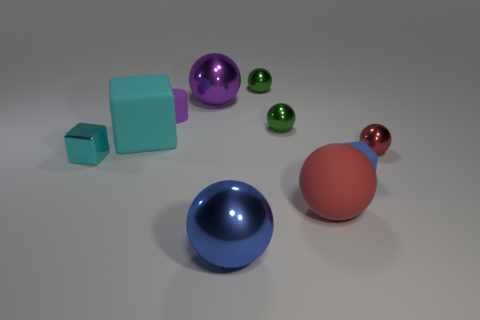Subtract all red balls. How many were subtracted if there are1red balls left? 1 Subtract all purple cylinders. How many cyan cubes are left? 2 Subtract all cyan rubber cubes. How many cubes are left? 2 Subtract all blue cubes. How many cubes are left? 2 Subtract all small red spheres. Subtract all small purple matte cylinders. How many objects are left? 8 Add 2 rubber cubes. How many rubber cubes are left? 4 Add 9 large green shiny balls. How many large green shiny balls exist? 9 Subtract 1 purple balls. How many objects are left? 9 Subtract all cubes. How many objects are left? 7 Subtract all brown balls. Subtract all brown cylinders. How many balls are left? 6 